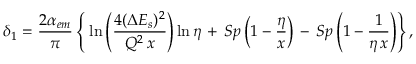<formula> <loc_0><loc_0><loc_500><loc_500>\delta _ { 1 } = { \frac { 2 \alpha _ { e m } } { \pi } } \left \{ \, \ln \left ( { \frac { 4 ( \Delta E _ { s } ) ^ { 2 } } { Q ^ { 2 } \, x } } \right ) \ln \eta \, + \, S p \left ( 1 - { \frac { \eta } { x } } \right ) \, - \, S p \left ( 1 - { \frac { 1 } { \eta \, x } } \right ) \right \} ,</formula> 